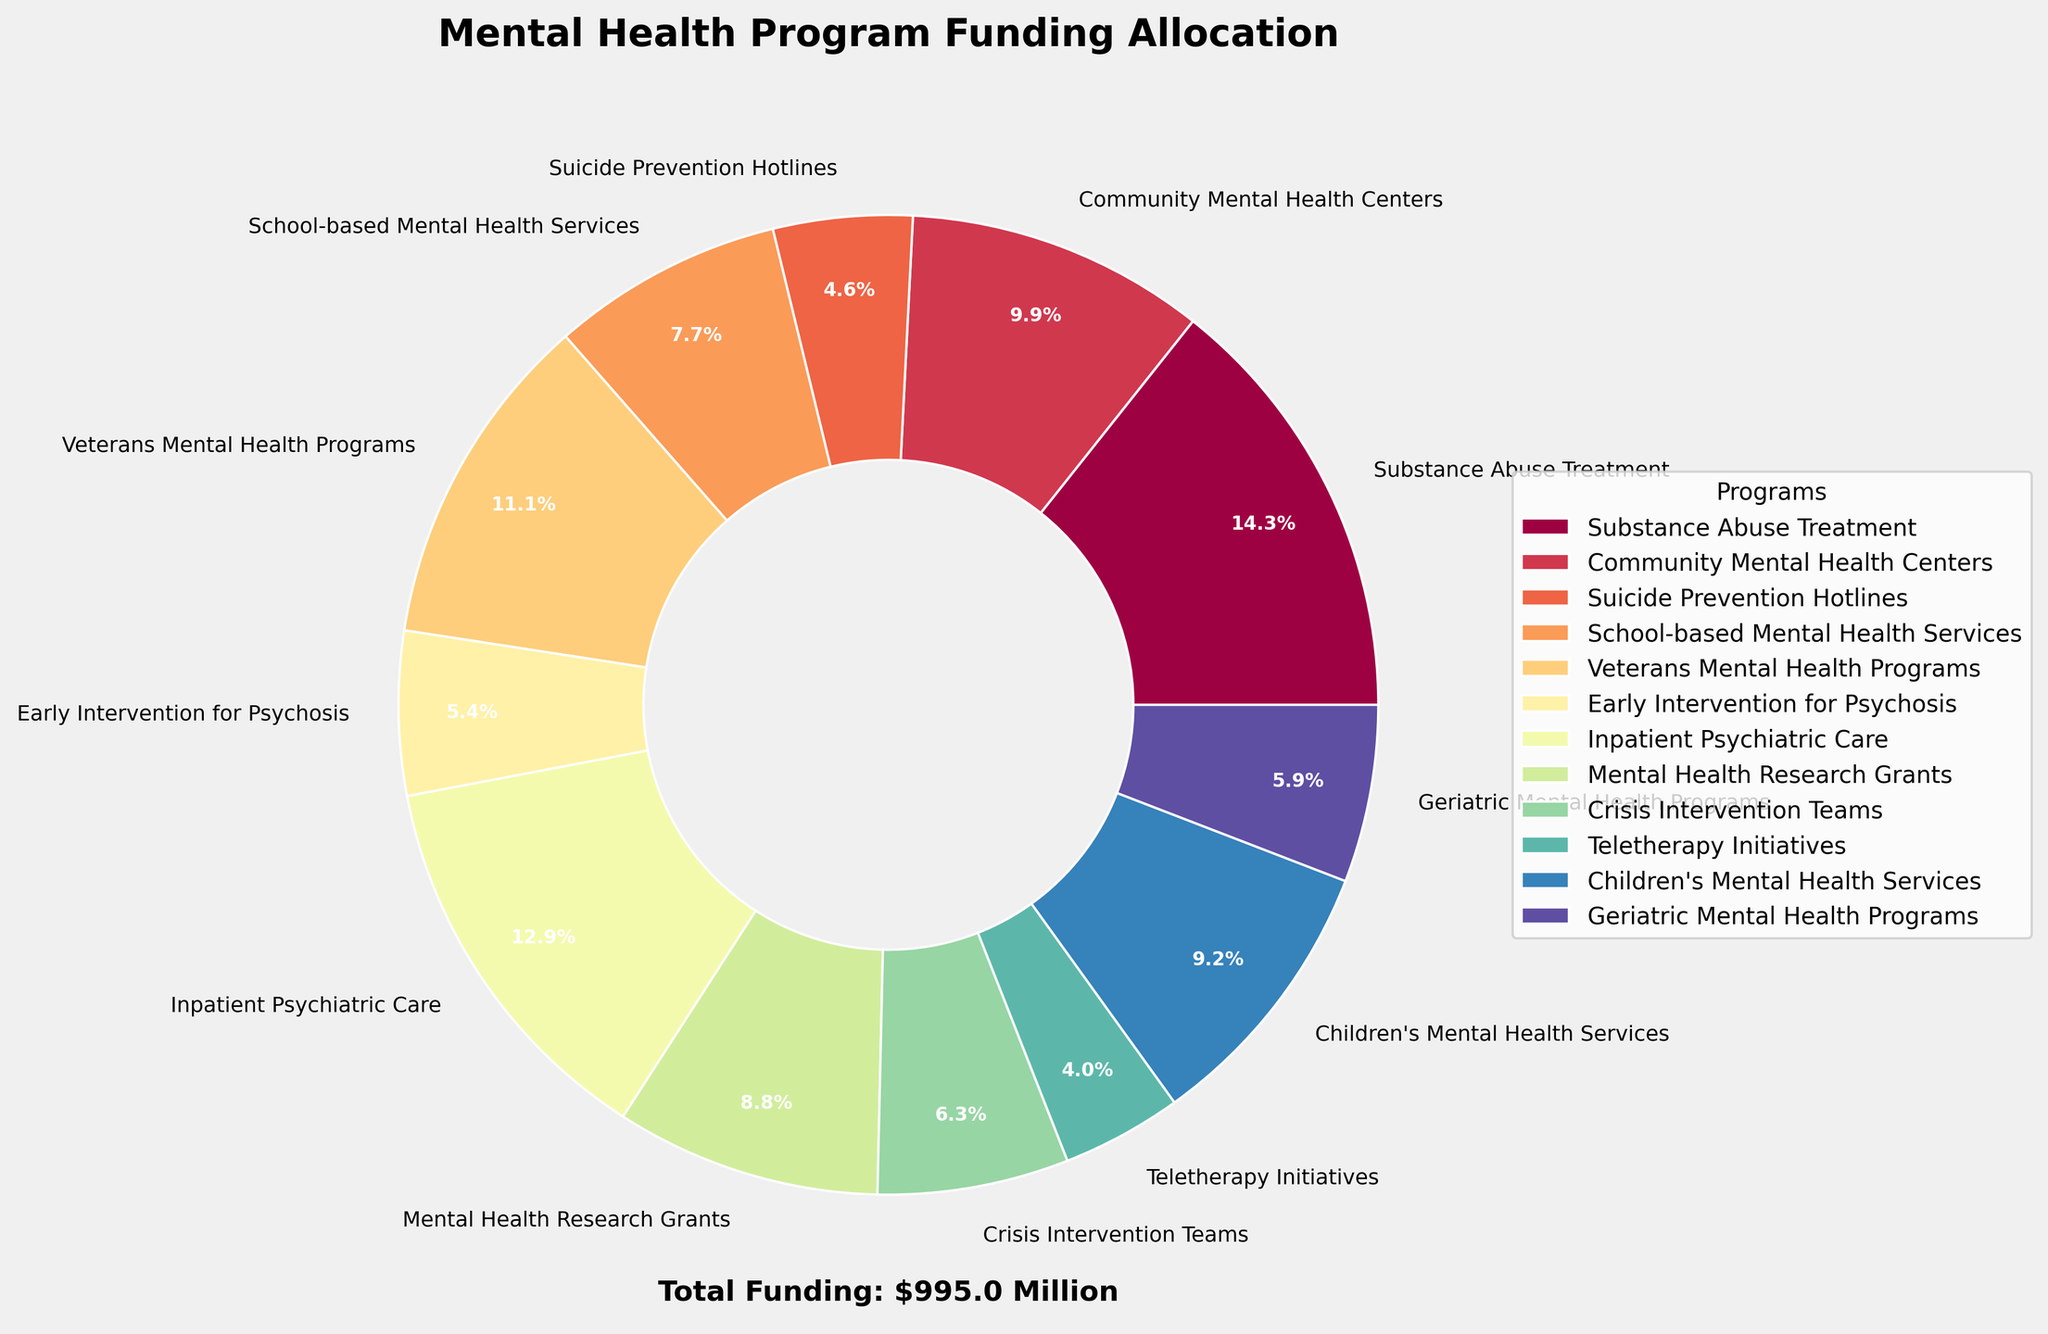What percentage of the total funding is allocated to Substance Abuse Treatment? The slice of the pie chart labeled "Substance Abuse Treatment" shows the percentage of the total funding allocated to that program. Identify the percentage label in the pie chart.
Answer: 16.4% Which program has the lowest funding allocation? The smallest slice on the pie chart corresponds to the program with the lowest funding allocation. Identify the slice with the smallest percentage label.
Answer: Teletherapy Initiatives How much more funding do Veterans Mental Health Programs receive compared to Community Mental Health Centers? First, identify the funding amounts for both programs from their respective slices in the pie chart. Veterans Mental Health Programs receive $110.6 million and Community Mental Health Centers receive $98.3 million. Subtract the funding amount for Community Mental Health Centers from that for Veterans Mental Health Programs.
Answer: $12.3 million What is the total funding allocated to School-based Mental Health Services and Early Intervention for Psychosis combined? Identify the funding amounts for both programs from their respective slices in the pie chart. School-based Mental Health Services have $76.2 million and Early Intervention for Psychosis has $53.9 million. Add these two amounts together.
Answer: $130.1 million Which program receives a higher percentage of funding: Crisis Intervention Teams or Children's Mental Health Services? Compare the percentage labels on the slices of the pie chart for Crisis Intervention Teams and Children's Mental Health Services. Identify which percentage is higher.
Answer: Children's Mental Health Services What is the average funding allocated among Inpatient Psychiatric Care, Mental Health Research Grants, and Geriatric Mental Health Programs? Identify the funding amounts for all three programs from their respective slices in the pie chart. Inpatient Psychiatric Care has $128.4 million, Mental Health Research Grants have $87.1 million, and Geriatric Mental Health Programs have $58.3 million. Sum these amounts and divide by three to find the average.
Answer: $91.27 million Which program's funding allocation is closest in value to Suicide Prevention Hotlines? Identify the funding amounts for all programs from their respective slices in the pie chart. Suicide Prevention Hotlines have $45.7 million. Find the program with a funding allocation closest to this value by comparing all other slices.
Answer: Geriatric Mental Health Programs If funding were increased by 10% for Community Mental Health Centers, what would the new funding amount be? Identify the current funding amount for Community Mental Health Centers from its slice in the pie chart, which is $98.3 million. Calculate 10% of this amount and add it to the original funding: $98.3 million * 0.10 = $9.83 million, so $98.3 million + $9.83 million = $108.13 million.
Answer: $108.13 million 